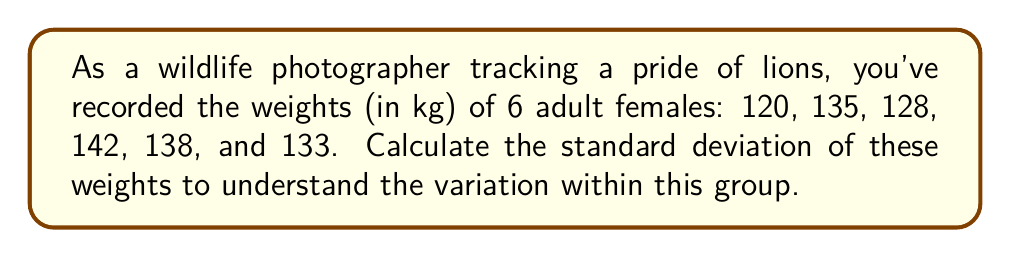Can you answer this question? To calculate the standard deviation, we'll follow these steps:

1. Calculate the mean (average) weight:
   $\bar{x} = \frac{120 + 135 + 128 + 142 + 138 + 133}{6} = 132.67$ kg

2. Calculate the squared differences from the mean:
   $(120 - 132.67)^2 = (-12.67)^2 = 160.53$
   $(135 - 132.67)^2 = (2.33)^2 = 5.43$
   $(128 - 132.67)^2 = (-4.67)^2 = 21.81$
   $(142 - 132.67)^2 = (9.33)^2 = 87.05$
   $(138 - 132.67)^2 = (5.33)^2 = 28.41$
   $(133 - 132.67)^2 = (0.33)^2 = 0.11$

3. Sum the squared differences:
   $160.53 + 5.43 + 21.81 + 87.05 + 28.41 + 0.11 = 303.34$

4. Divide by (n-1) = 5 to get the variance:
   $s^2 = \frac{303.34}{5} = 60.67$

5. Take the square root to get the standard deviation:
   $s = \sqrt{60.67} = 7.79$ kg

The standard deviation is approximately 7.79 kg.
Answer: 7.79 kg 